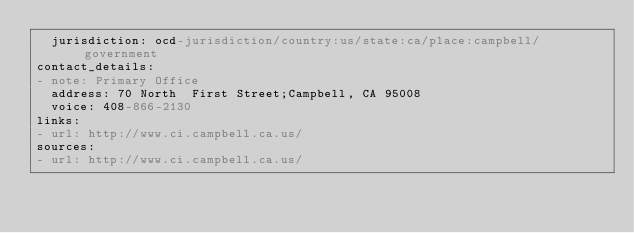Convert code to text. <code><loc_0><loc_0><loc_500><loc_500><_YAML_>  jurisdiction: ocd-jurisdiction/country:us/state:ca/place:campbell/government
contact_details:
- note: Primary Office
  address: 70 North  First Street;Campbell, CA 95008
  voice: 408-866-2130
links:
- url: http://www.ci.campbell.ca.us/
sources:
- url: http://www.ci.campbell.ca.us/
</code> 